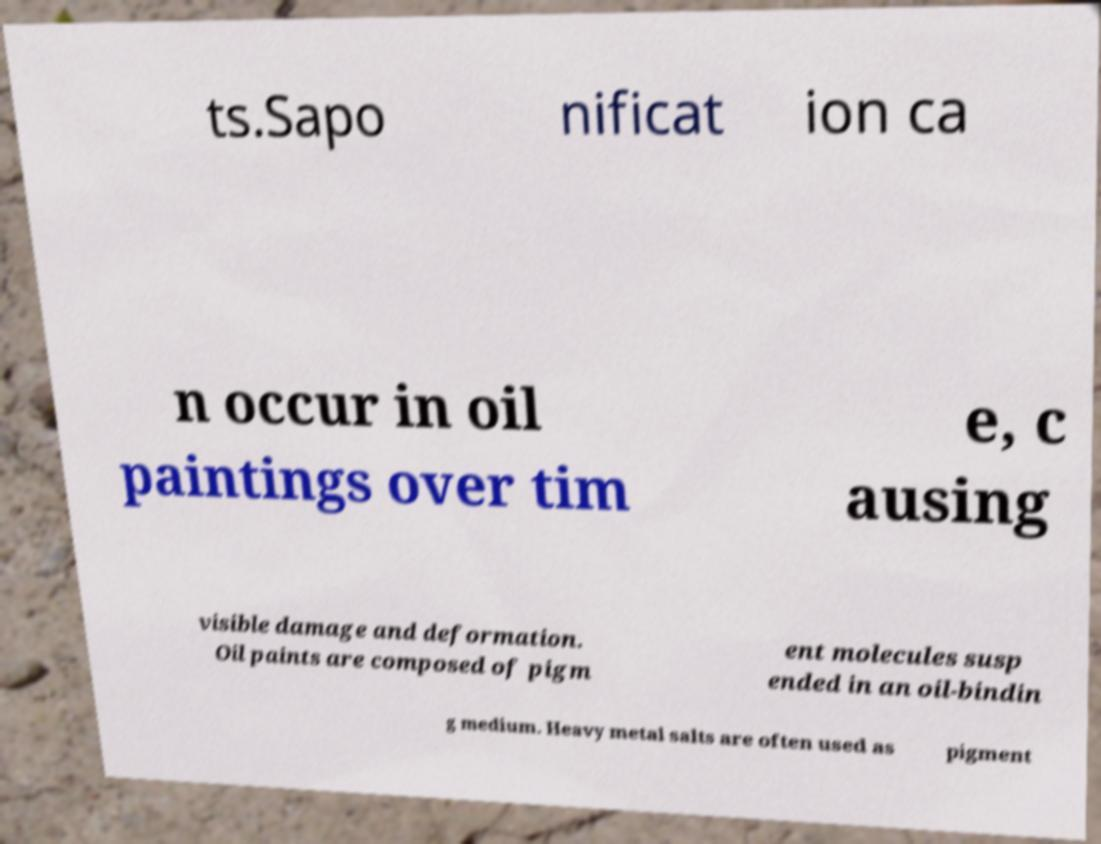There's text embedded in this image that I need extracted. Can you transcribe it verbatim? ts.Sapo nificat ion ca n occur in oil paintings over tim e, c ausing visible damage and deformation. Oil paints are composed of pigm ent molecules susp ended in an oil-bindin g medium. Heavy metal salts are often used as pigment 